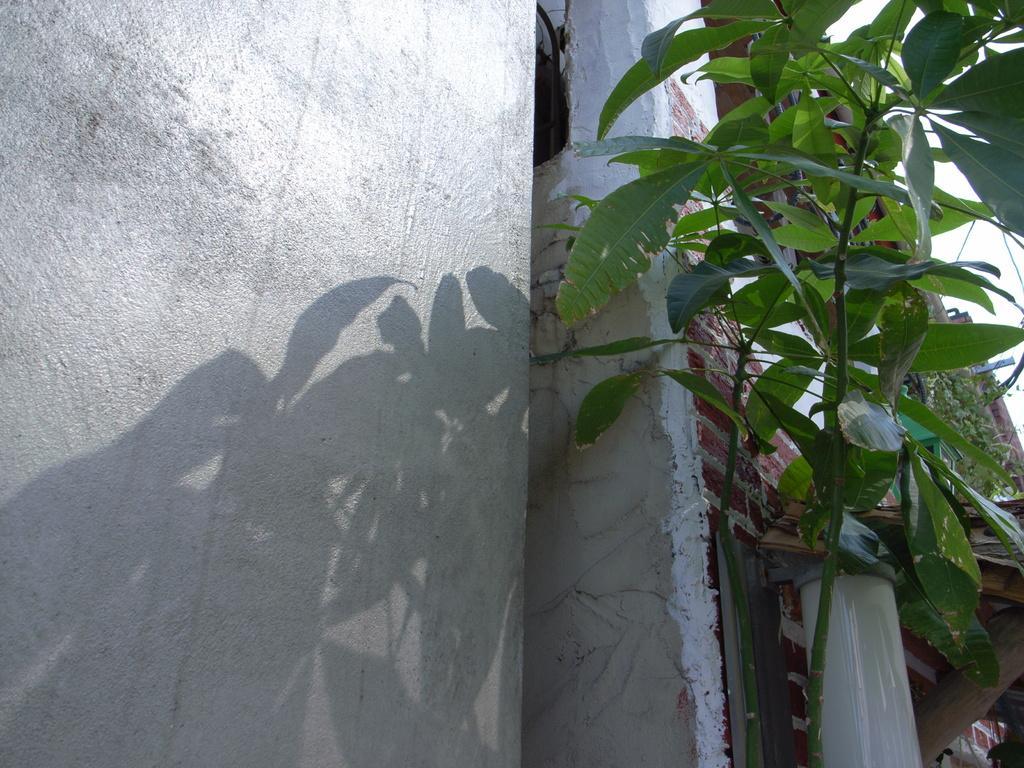Please provide a concise description of this image. In this image we can see a plant in front of the wall and a pipe attached to the wall and sky in the background. 